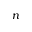Convert formula to latex. <formula><loc_0><loc_0><loc_500><loc_500>n</formula> 